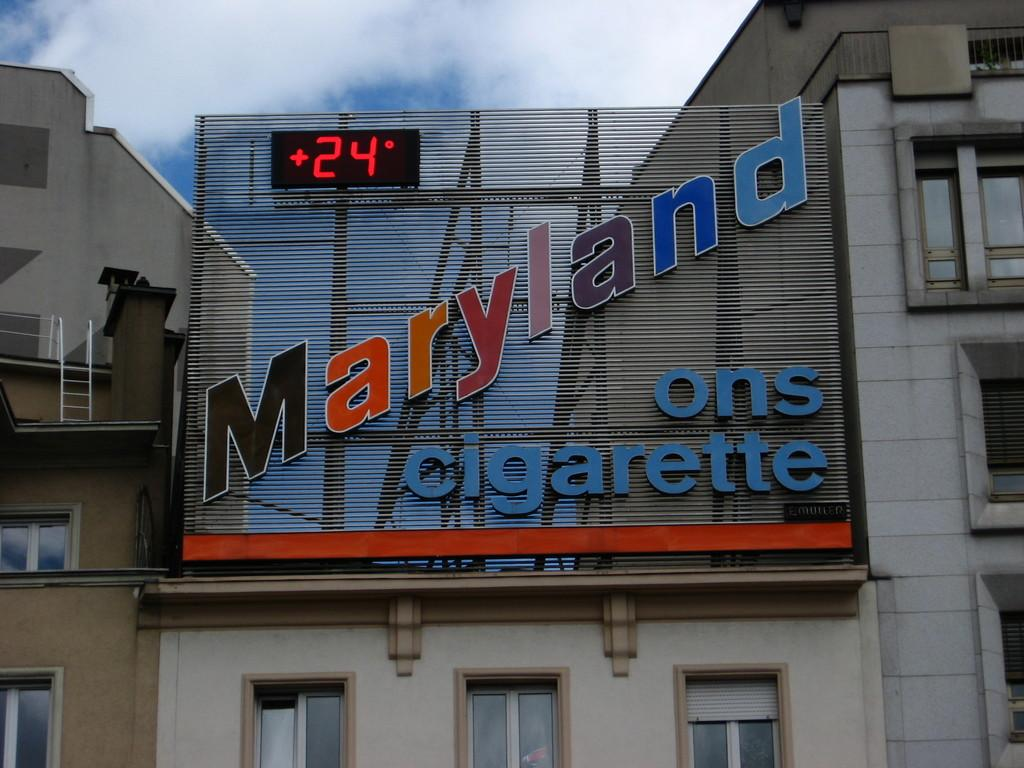What type of structures can be seen in the image? There are buildings in the image. What type of advertisement or announcement is present in the image? There is a hoarding in the image. What type of display or screen is present in the image? There is a led screen in the image. What can be seen in the sky in the image? Clouds are visible in the sky. What is located on the left side of the image? There is a metal ladder on the left side of the image. What type of baseball behavior can be observed in the image? There is no baseball or related behavior present in the image. How does the sleet affect the buildings in the image? There is no sleet present in the image; it is not raining or snowing. 